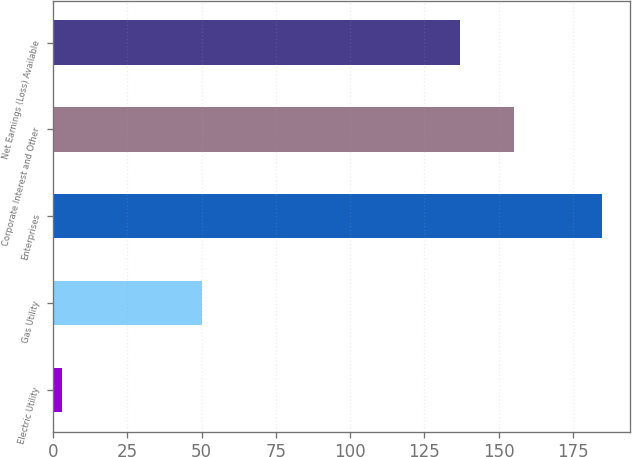<chart> <loc_0><loc_0><loc_500><loc_500><bar_chart><fcel>Electric Utility<fcel>Gas Utility<fcel>Enterprises<fcel>Corporate Interest and Other<fcel>Net Earnings (Loss) Available<nl><fcel>3<fcel>50<fcel>185<fcel>155.2<fcel>137<nl></chart> 